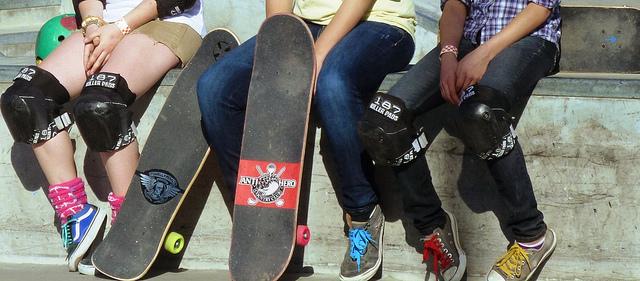How many kids are there?
Give a very brief answer. 3. Are they all wearing knee pads?
Write a very short answer. No. How many skateboards are there?
Give a very brief answer. 2. 